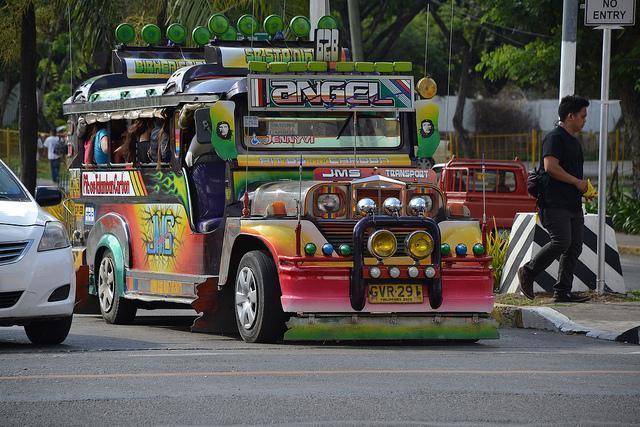How many people can you see?
Give a very brief answer. 1. 